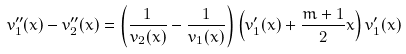<formula> <loc_0><loc_0><loc_500><loc_500>v ^ { \prime \prime } _ { 1 } ( x ) - v ^ { \prime \prime } _ { 2 } ( x ) = \left ( \frac { 1 } { v _ { 2 } ( x ) } - \frac { 1 } { v _ { 1 } ( x ) } \right ) \left ( v ^ { \prime } _ { 1 } ( x ) + \frac { m + 1 } { 2 } x \right ) v ^ { \prime } _ { 1 } ( x )</formula> 